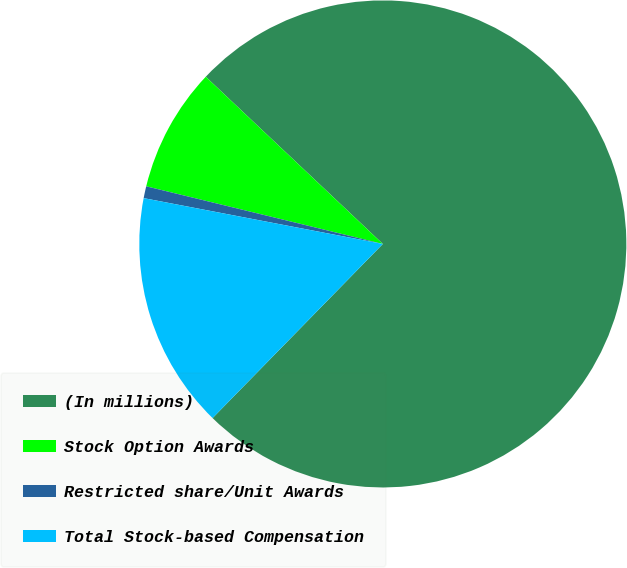<chart> <loc_0><loc_0><loc_500><loc_500><pie_chart><fcel>(In millions)<fcel>Stock Option Awards<fcel>Restricted share/Unit Awards<fcel>Total Stock-based Compensation<nl><fcel>75.27%<fcel>8.24%<fcel>0.79%<fcel>15.69%<nl></chart> 